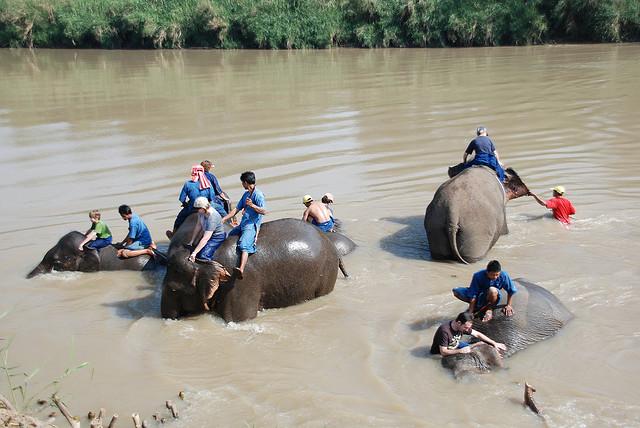Is the water clear?
Concise answer only. No. What are they riding?
Quick response, please. Elephants. Is the water clean and clear?
Answer briefly. No. 